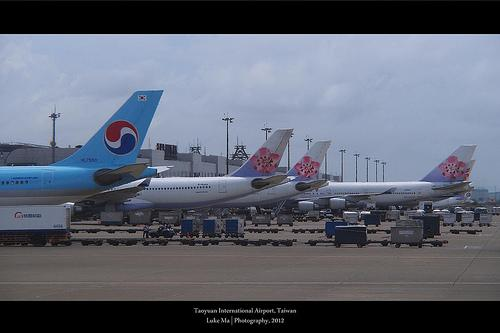What is the overall sentiment conveyed by the image? The image conveys a busy and bustling atmosphere at an airport terminal as several airplanes are being serviced. Is there any interaction among objects or people in the image? If so, explain the situation. An aircraft mechanic crew member is interacting with a luggage tow vehicle, possibly coordinating the movement of luggage carts. How many clouds are shown in the image, and what does the sky look like? There are eight distinct white clouds in a blue sky. Identify and describe any unique features on the tail fins of the airplanes in the image. There are pink flowers on some tail fins, a red, white, and blue swirl on another, and a South Korean flag on another plane's tail fin. Count the number of airplanes in the image and describe their distinctive characteristics. There are five airplanes, each having a different tail logo – one with the South Korean flag, others with pink flowers, and one with a red, white, and blue swirl. What types of vehicles are visible in the image around the airplanes? Luggage carts, tow vehicles, trucks, and white service vehicles are present around the aircraft. What additional information can you discern about the airport's environment based on the ground markings and surrounding features? The airport has gray pavement on the tarmac, white and yellow painted lines, light poles, and appears to be surrounded by cloudy white skies. Provide a brief description of the primary objects present in the image. Several jet airplanes with colorful tail logos being serviced at their gates, luggage boxes, service vehicles, a mechanic crew member, and an airport terminal with an antenna and lights. Examine the airport infrastructure present in the image and list all the elements. The airport infrastructure includes a terminal with an antenna on its roof, terminal gate lights, taxiway line, and light poles. What is happening with the luggage and service vehicles in the image? Luggage boxes are placed behind the aircraft, and service vehicles, including white trucks, are moving around the area for various tasks. 